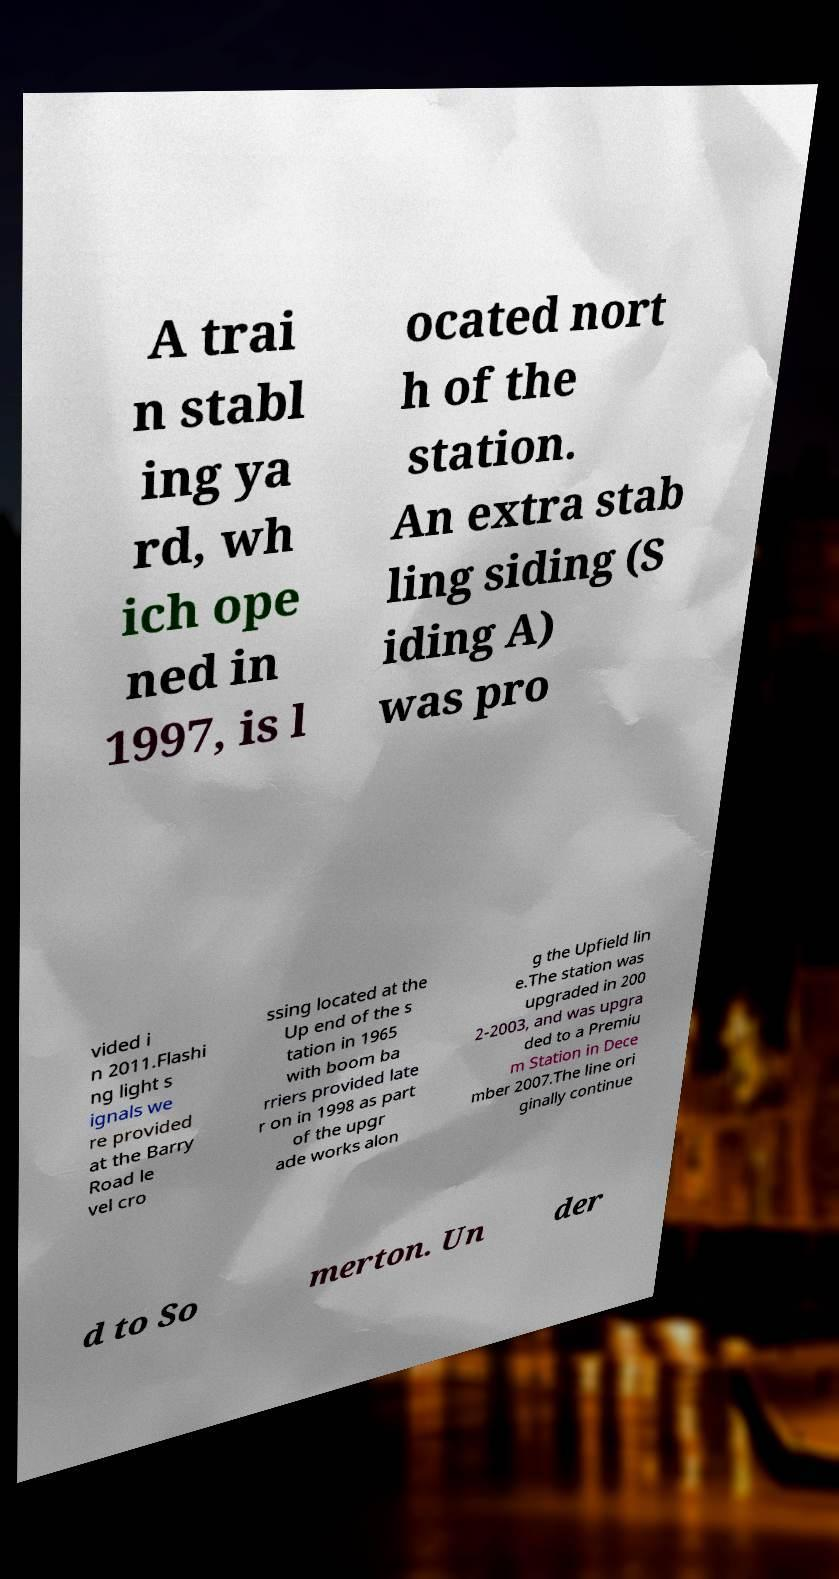Please read and relay the text visible in this image. What does it say? A trai n stabl ing ya rd, wh ich ope ned in 1997, is l ocated nort h of the station. An extra stab ling siding (S iding A) was pro vided i n 2011.Flashi ng light s ignals we re provided at the Barry Road le vel cro ssing located at the Up end of the s tation in 1965 with boom ba rriers provided late r on in 1998 as part of the upgr ade works alon g the Upfield lin e.The station was upgraded in 200 2-2003, and was upgra ded to a Premiu m Station in Dece mber 2007.The line ori ginally continue d to So merton. Un der 